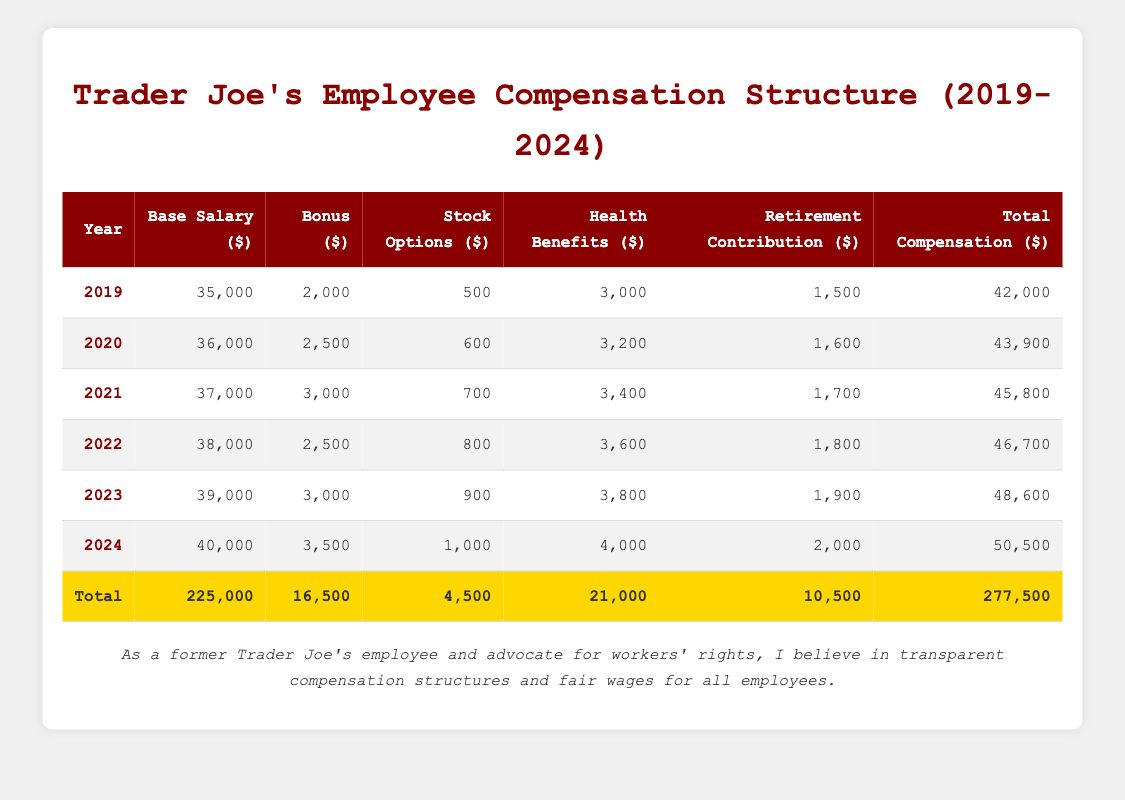What was the total compensation for employees in 2022? From the table, the total compensation for the year 2022 is listed as 46,700.
Answer: 46,700 What was the base salary increase from 2019 to 2024? The base salary in 2019 was 35,000 and in 2024 it is 40,000. The increase is 40,000 - 35,000 = 5,000.
Answer: 5,000 Was the bonus in 2021 higher than the bonus in 2020? The bonus for 2021 is listed as 3,000 and for 2020 is 2,500. Since 3,000 is greater than 2,500, the statement is true.
Answer: Yes What was the average health benefits amount over the 5 years? The health benefits for the years 2019 to 2023 are 3,000; 3,200; 3,400; 3,600; 3,800; and 4,000. Summing these gives 3,000 + 3,200 + 3,400 + 3,600 + 3,800 + 4,000 = 20,000. Dividing by 6 (the number of years) gives 20,000 / 6 = 3,333.33.
Answer: 3,333.33 How much did the total compensation increase from 2021 to 2024? The total compensation for 2021 is 46,600 and for 2024 is 50,500. The difference is 50,500 - 46,600 = 3,900.
Answer: 3,900 Did the stock options increase consistently every year from 2019 to 2024? The stock options data shows increases as follows: 500 (2019), 600 (2020), 700 (2021), 800 (2022), 900 (2023), and 1,000 (2024). Since each year the value is higher than the previous year, the statement is true.
Answer: Yes What is the sum of the retirement contributions from 2019 to 2024? The retirement contributions for the specified years are 1,500; 1,600; 1,700; 1,800; 1,900; and 2,000. Summing these gives 1,500 + 1,600 + 1,700 + 1,800 + 1,900 + 2,000 = 10,500.
Answer: 10,500 What percentage of the total compensation for 2024 is made up of stock options? The total compensation for 2024 is 50,500 and the stock options for that year is 1,000. The percentage is (1,000 / 50,500) * 100 = 1.98%.
Answer: 1.98% What year had the highest total compensation? By comparing the total compensation values, 2024 has the highest total at 50,500.
Answer: 2024 